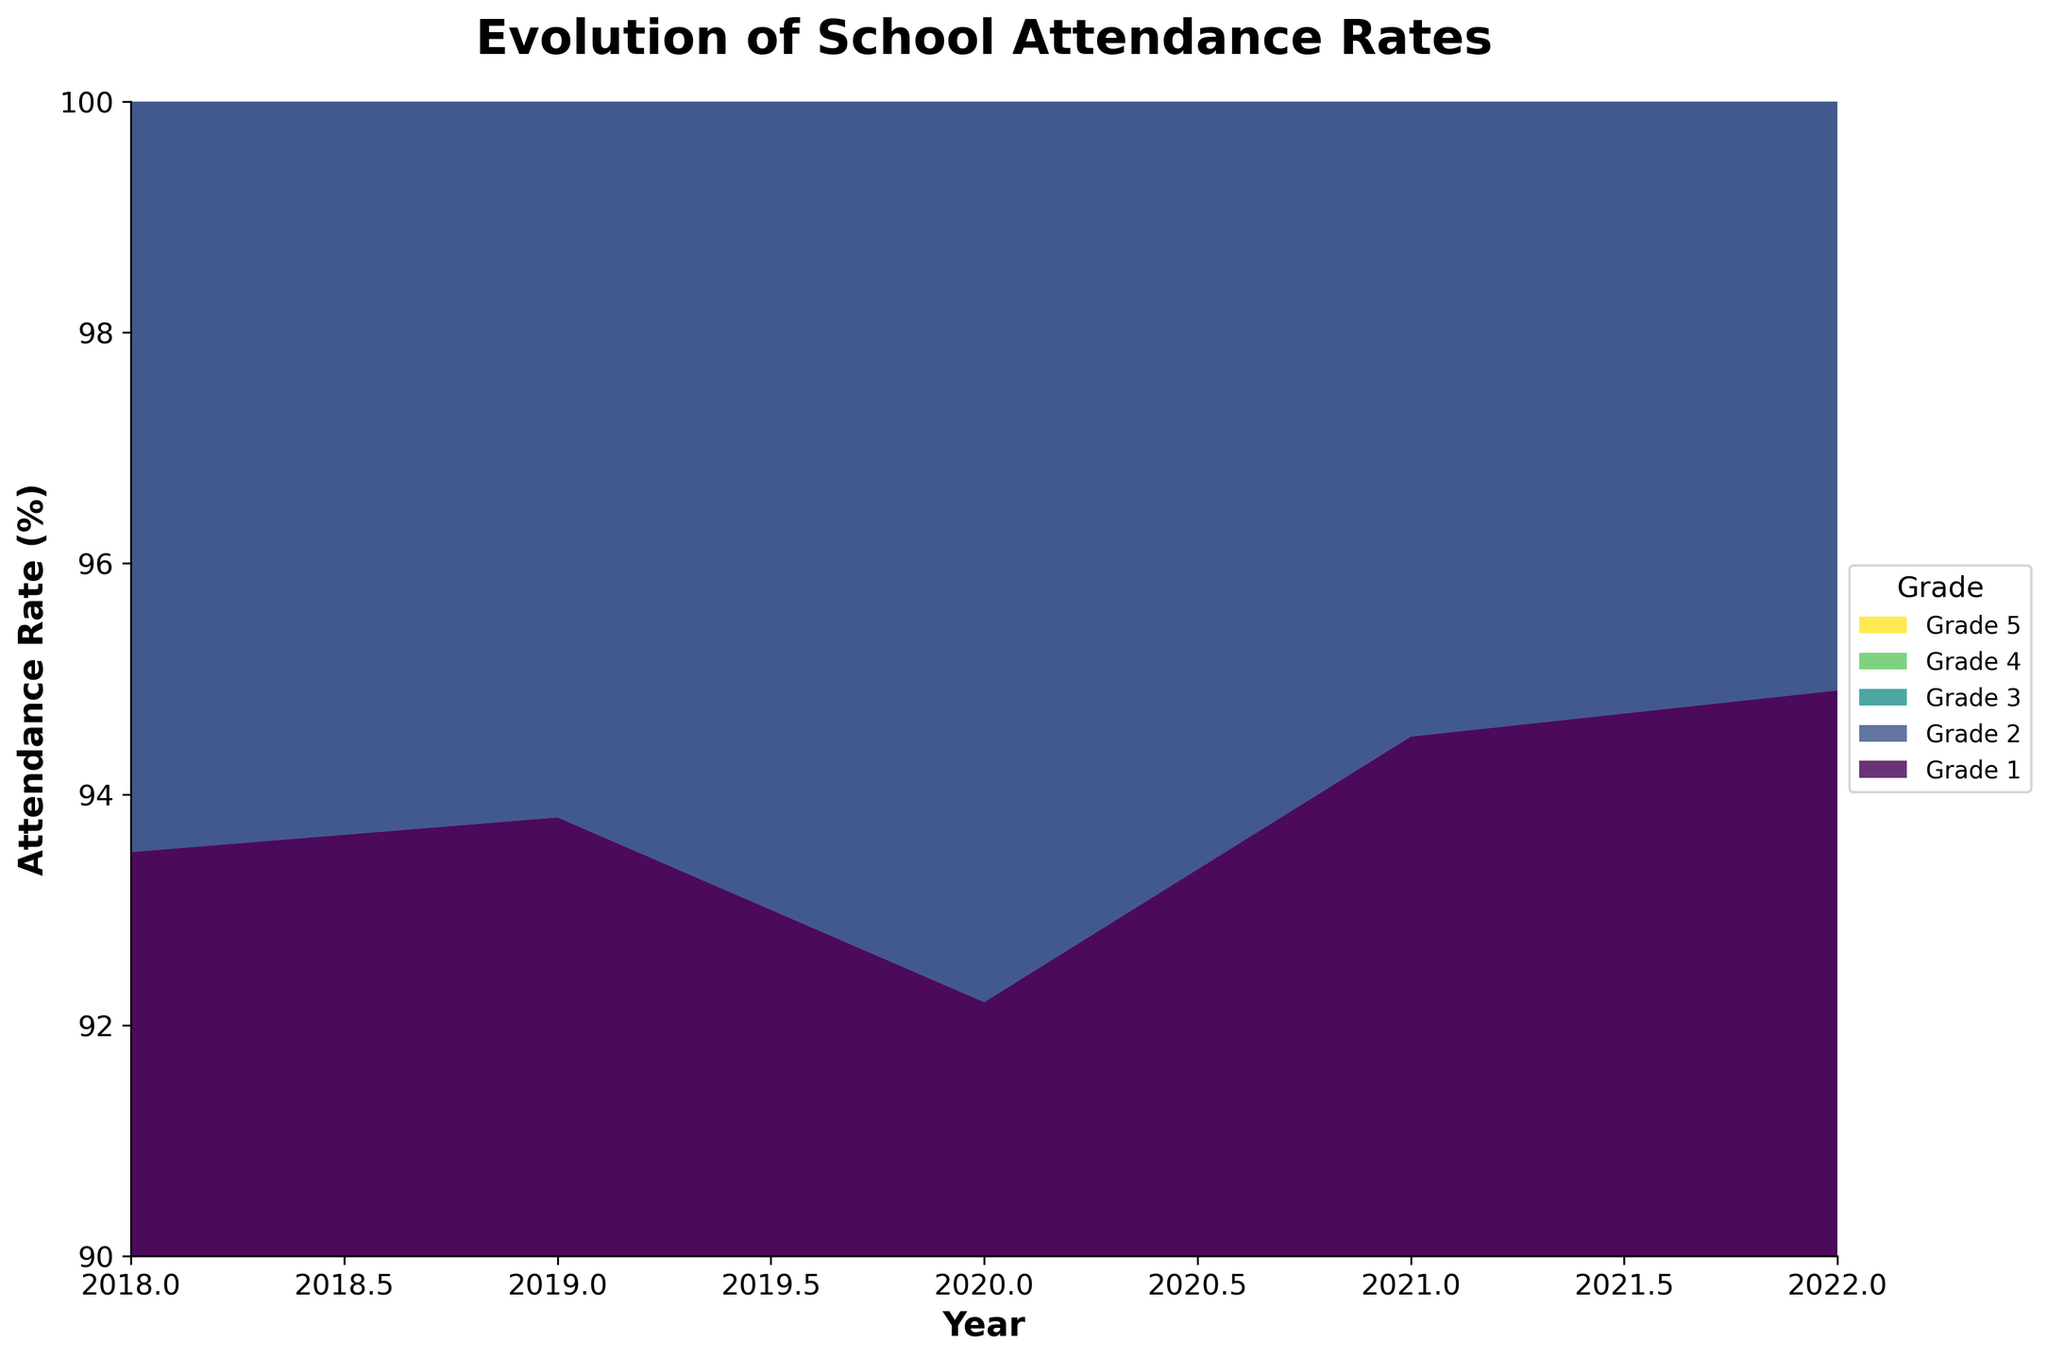What is the year range covered in the figure? The x-axis in the figure shows the years from 2018 to 2022. The year range is clearly labeled along the bottom of the graph.
Answer: 2018-2022 Which grade has the highest attendance rate in the most recent year displayed? The topmost layer of the stream graph in the year 2022 shows the attendance rate. By examining the layers, Grade 5 is at the topmost position, indicating it has the highest attendance rate.
Answer: Grade 5 What trend can be observed in the attendance rates of Grade 1 and Grade 5 over the years? By following the separate layers for Grade 1 and Grade 5, one can notice that Grade 1's attendance rate fluctuated but generally increased from 2018 to 2022, while Grade 5's attendance rate consistently increased.
Answer: Increasing How much did the attendance rate for Grade 3 change between 2020 and 2021? Look at the layer corresponding to Grade 3 for the years 2020 and 2021. The values are 93.9 and 95.2, respectively. The difference is 95.2 - 93.9.
Answer: 1.3% Which year had the lowest overall attendance rate for all grades combined? Observing the width of all layers combined at the bottom of the y-axis for each year, 2020 has the narrowest combined width, indicating the lowest overall attendance rate.
Answer: 2020 Did the attendance rate for any grade drop between any consecutive years? Examining each layer closely, the attendance rate for Grade 1 dropped from 2019 (93.8) to 2020 (92.2).
Answer: Yes Compare the attendance rate of Grade 2 and Grade 4 in the year 2021. Which one is higher? In 2021, the layer for Grade 4 is higher than that for Grade 2. Looking at the y-axis values, Grade 4's attendance rate is 95.6%, while Grade 2's is 95.0%.
Answer: Grade 4 What is the overall trend in school attendance rates from 2018 to 2022 for all grades? Observing the stream graph as a whole, all grade lines generally show an increasing trend over the years, indicating that attendance rates have improved over time.
Answer: Increasing Which grade experienced the largest increase in attendance rate from 2020 to 2021? By comparing the width of all layers between 2020 and 2021, Grade 1 shows a significant increase from 92.2% to 94.5%, the largest increment among all grades.
Answer: Grade 1 